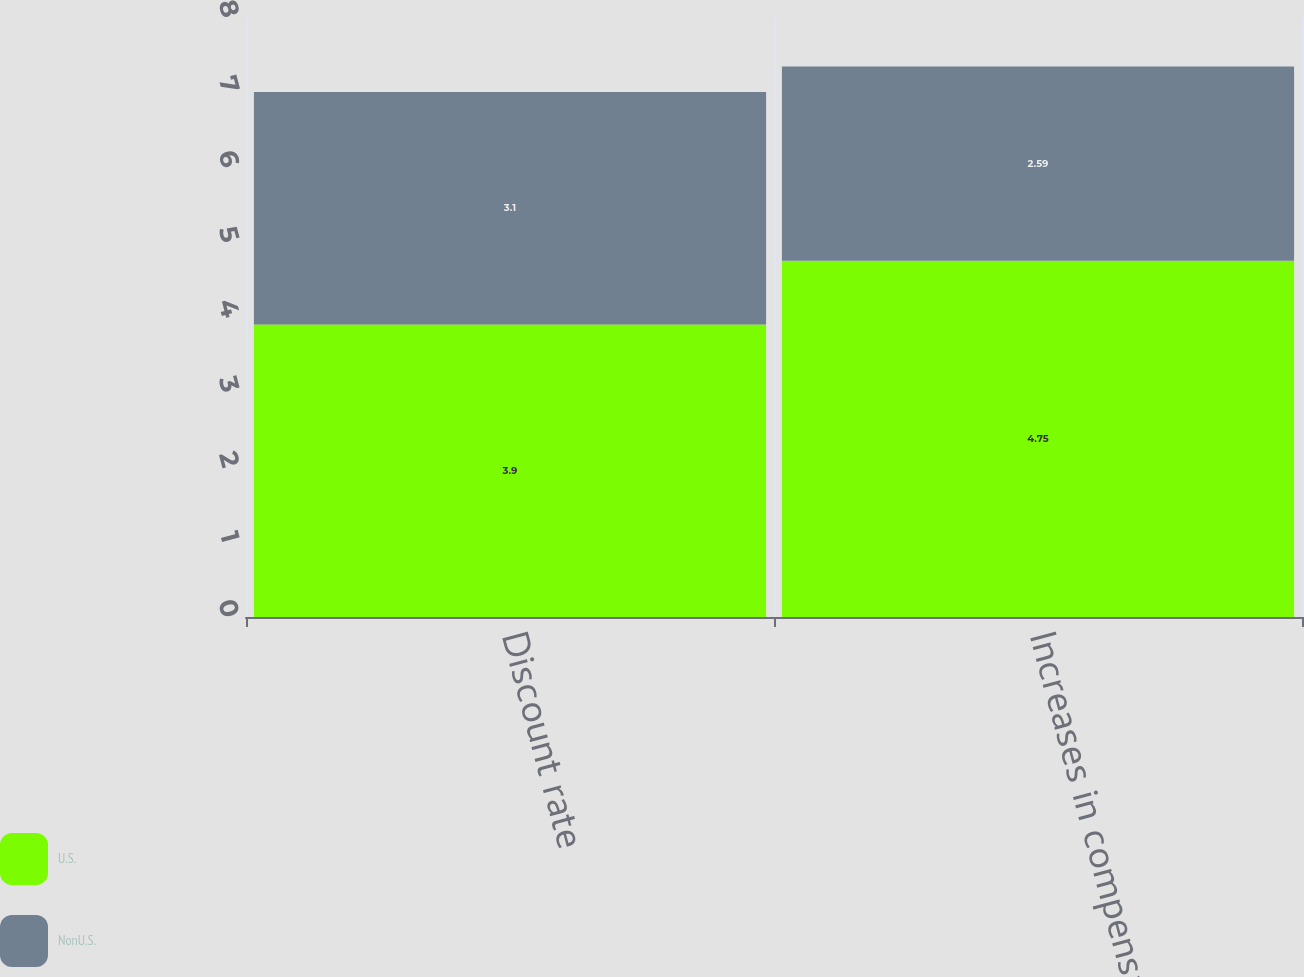<chart> <loc_0><loc_0><loc_500><loc_500><stacked_bar_chart><ecel><fcel>Discount rate<fcel>Increases in compensation<nl><fcel>U.S.<fcel>3.9<fcel>4.75<nl><fcel>NonU.S.<fcel>3.1<fcel>2.59<nl></chart> 